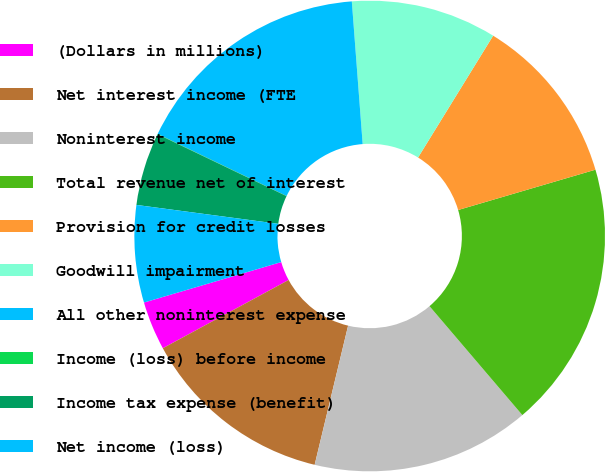<chart> <loc_0><loc_0><loc_500><loc_500><pie_chart><fcel>(Dollars in millions)<fcel>Net interest income (FTE<fcel>Noninterest income<fcel>Total revenue net of interest<fcel>Provision for credit losses<fcel>Goodwill impairment<fcel>All other noninterest expense<fcel>Income (loss) before income<fcel>Income tax expense (benefit)<fcel>Net income (loss)<nl><fcel>3.35%<fcel>13.33%<fcel>14.99%<fcel>18.31%<fcel>11.66%<fcel>10.0%<fcel>16.65%<fcel>0.02%<fcel>5.01%<fcel>6.67%<nl></chart> 